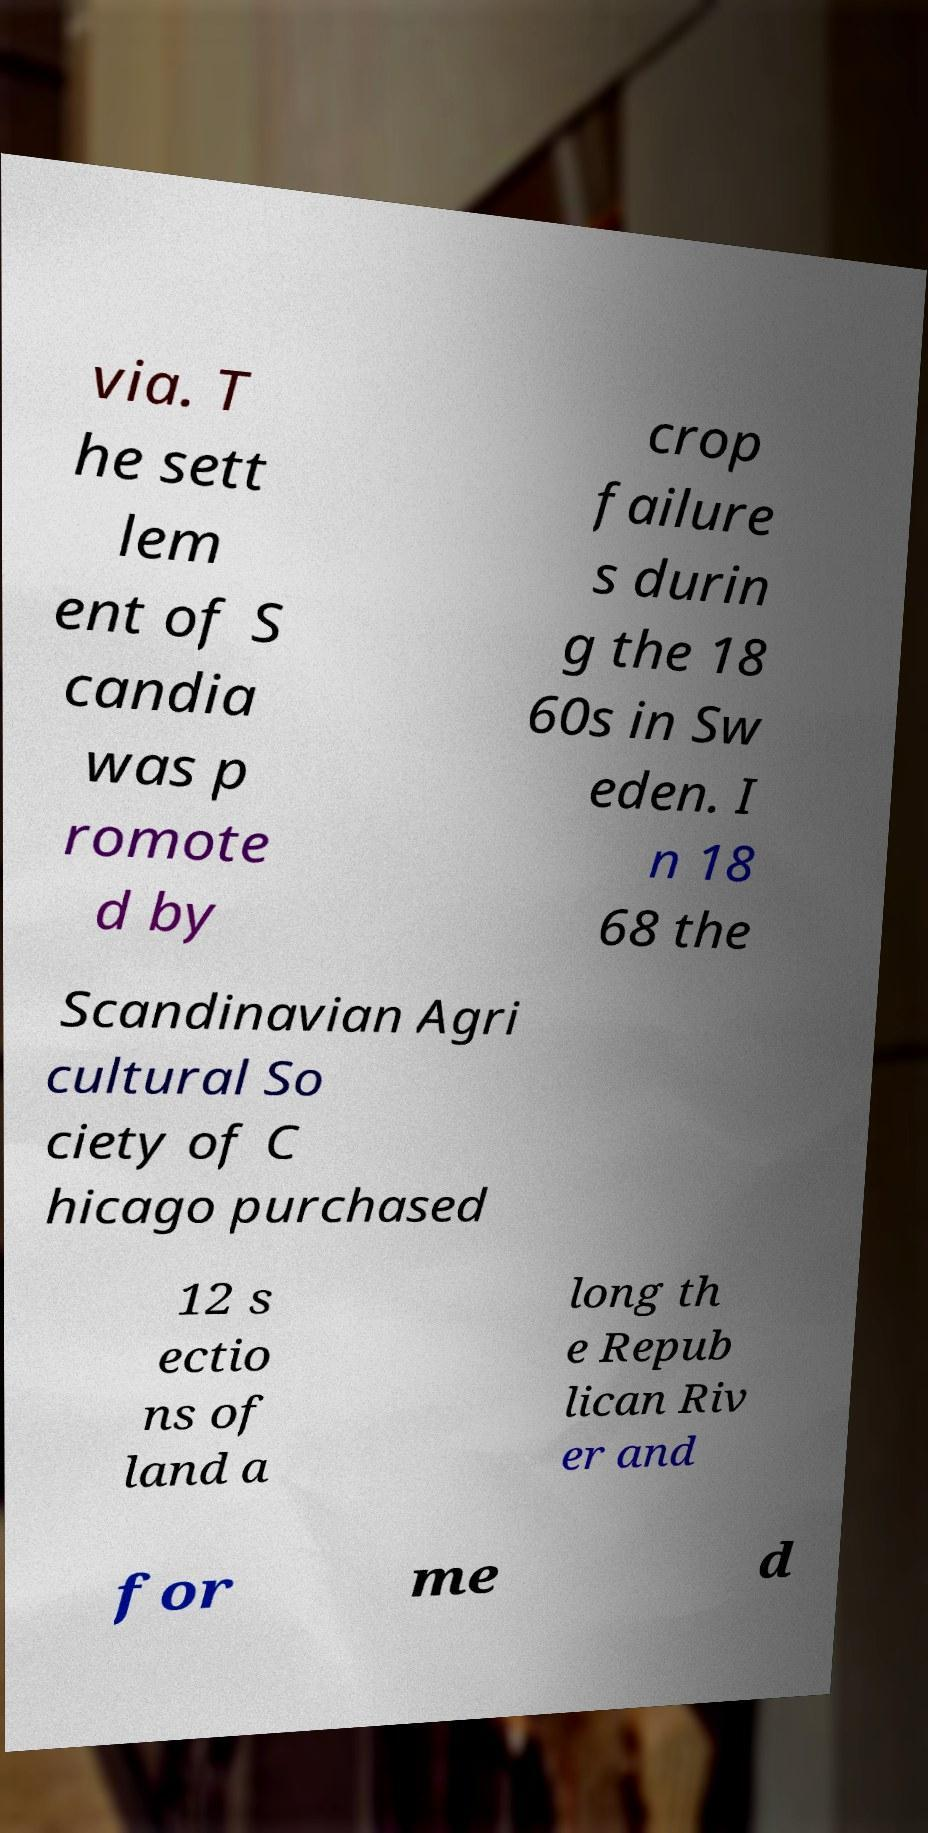Can you read and provide the text displayed in the image?This photo seems to have some interesting text. Can you extract and type it out for me? via. T he sett lem ent of S candia was p romote d by crop failure s durin g the 18 60s in Sw eden. I n 18 68 the Scandinavian Agri cultural So ciety of C hicago purchased 12 s ectio ns of land a long th e Repub lican Riv er and for me d 